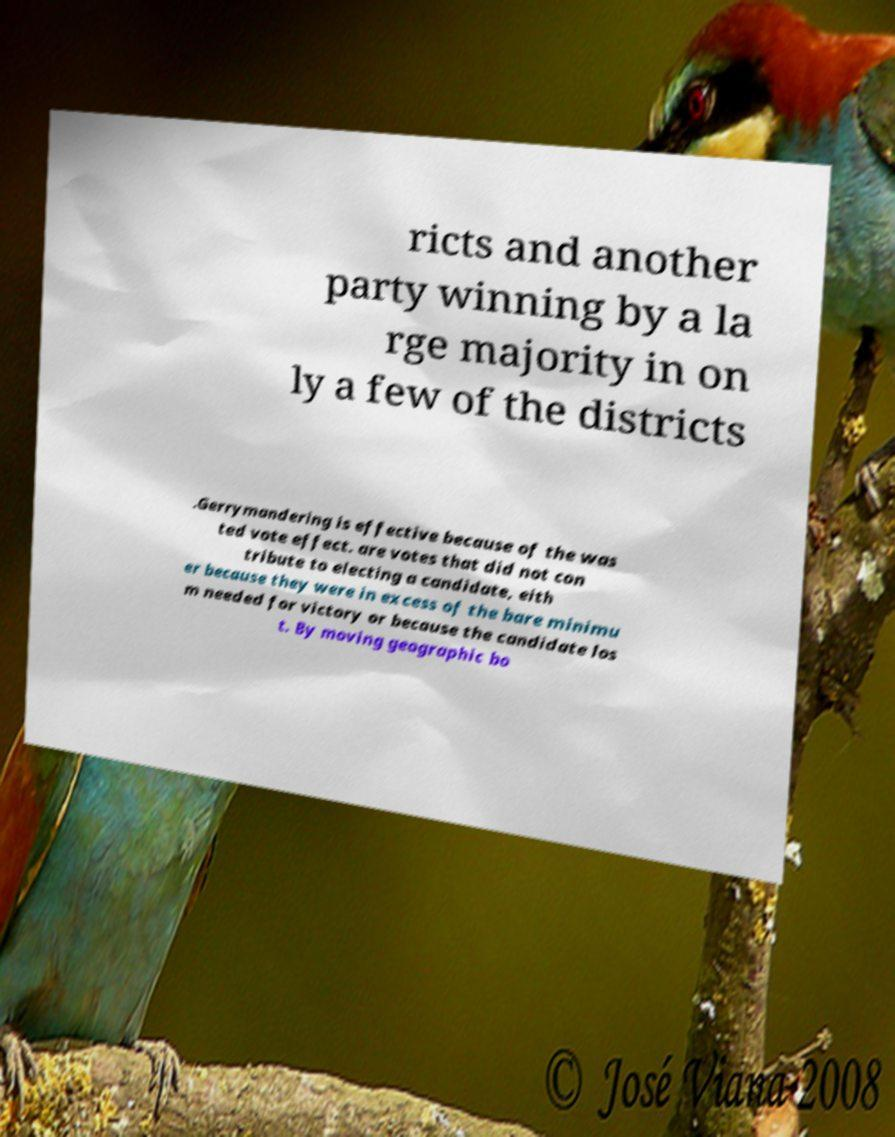Please read and relay the text visible in this image. What does it say? ricts and another party winning by a la rge majority in on ly a few of the districts .Gerrymandering is effective because of the was ted vote effect. are votes that did not con tribute to electing a candidate, eith er because they were in excess of the bare minimu m needed for victory or because the candidate los t. By moving geographic bo 